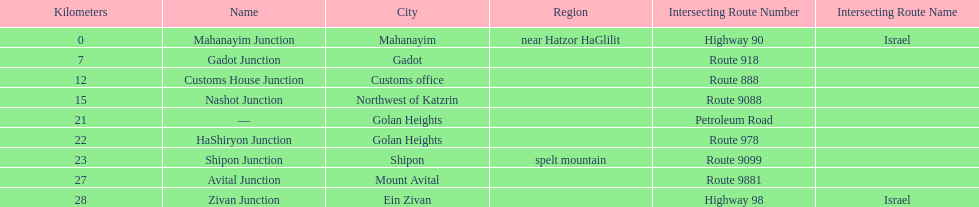What is the last junction on highway 91? Zivan Junction. 